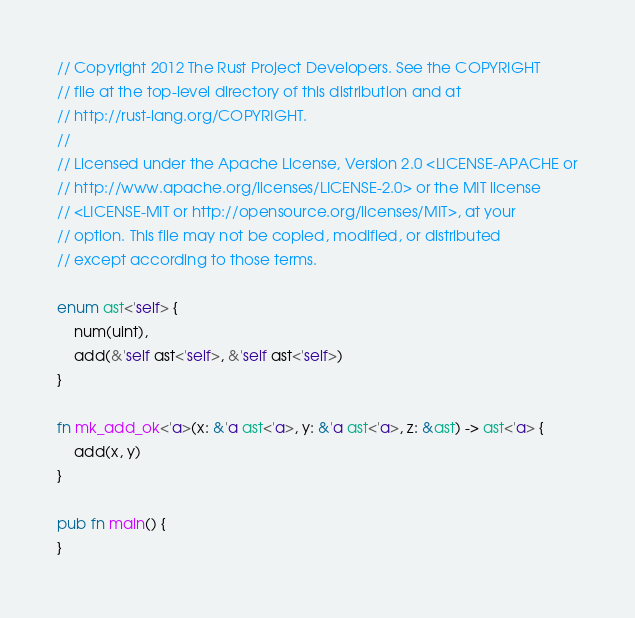Convert code to text. <code><loc_0><loc_0><loc_500><loc_500><_Rust_>// Copyright 2012 The Rust Project Developers. See the COPYRIGHT
// file at the top-level directory of this distribution and at
// http://rust-lang.org/COPYRIGHT.
//
// Licensed under the Apache License, Version 2.0 <LICENSE-APACHE or
// http://www.apache.org/licenses/LICENSE-2.0> or the MIT license
// <LICENSE-MIT or http://opensource.org/licenses/MIT>, at your
// option. This file may not be copied, modified, or distributed
// except according to those terms.

enum ast<'self> {
    num(uint),
    add(&'self ast<'self>, &'self ast<'self>)
}

fn mk_add_ok<'a>(x: &'a ast<'a>, y: &'a ast<'a>, z: &ast) -> ast<'a> {
    add(x, y)
}

pub fn main() {
}
</code> 